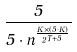<formula> <loc_0><loc_0><loc_500><loc_500>\frac { 5 } { 5 \cdot n ^ { \frac { K \times ( 5 \cdot K ) } { 2 ^ { T + 5 } } } }</formula> 